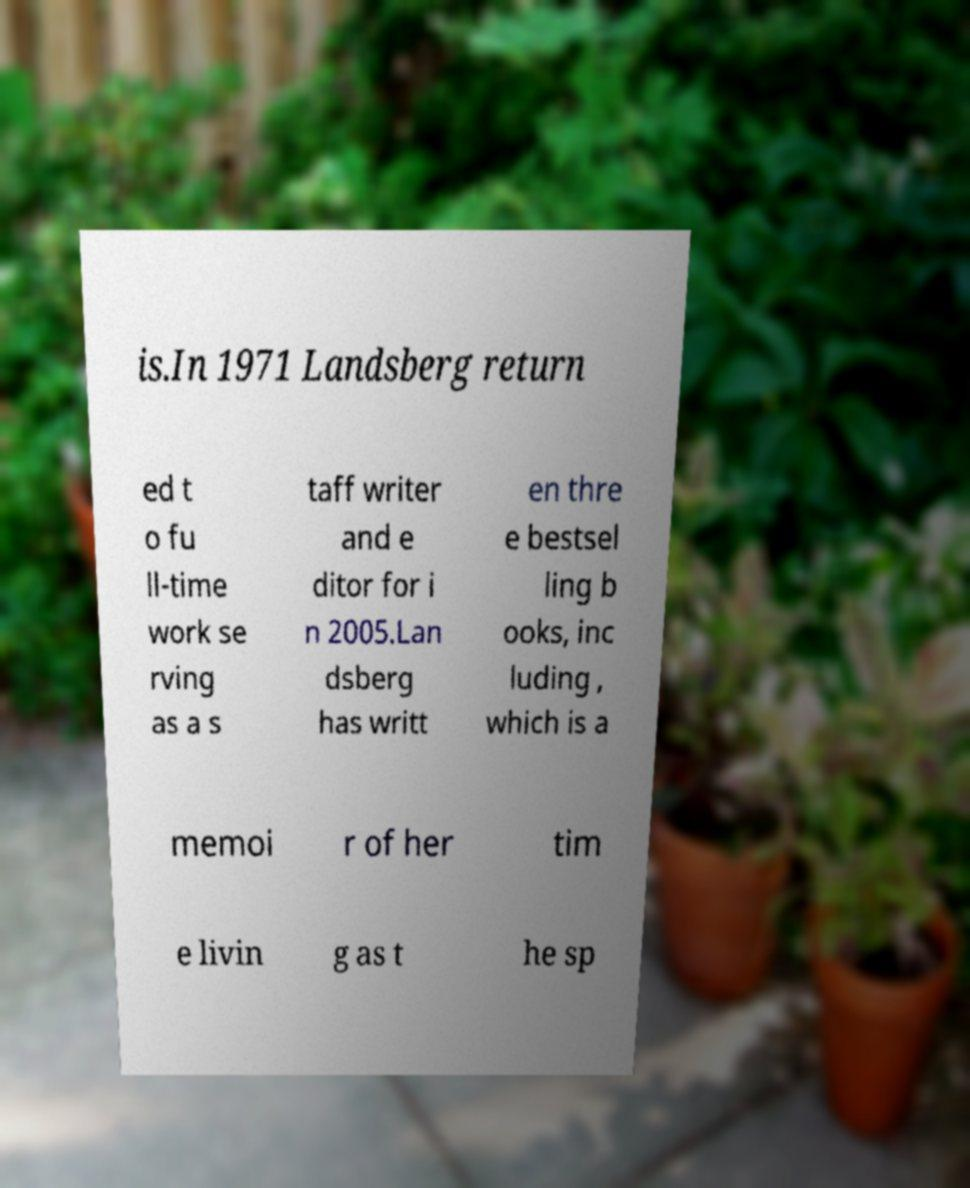What messages or text are displayed in this image? I need them in a readable, typed format. is.In 1971 Landsberg return ed t o fu ll-time work se rving as a s taff writer and e ditor for i n 2005.Lan dsberg has writt en thre e bestsel ling b ooks, inc luding , which is a memoi r of her tim e livin g as t he sp 